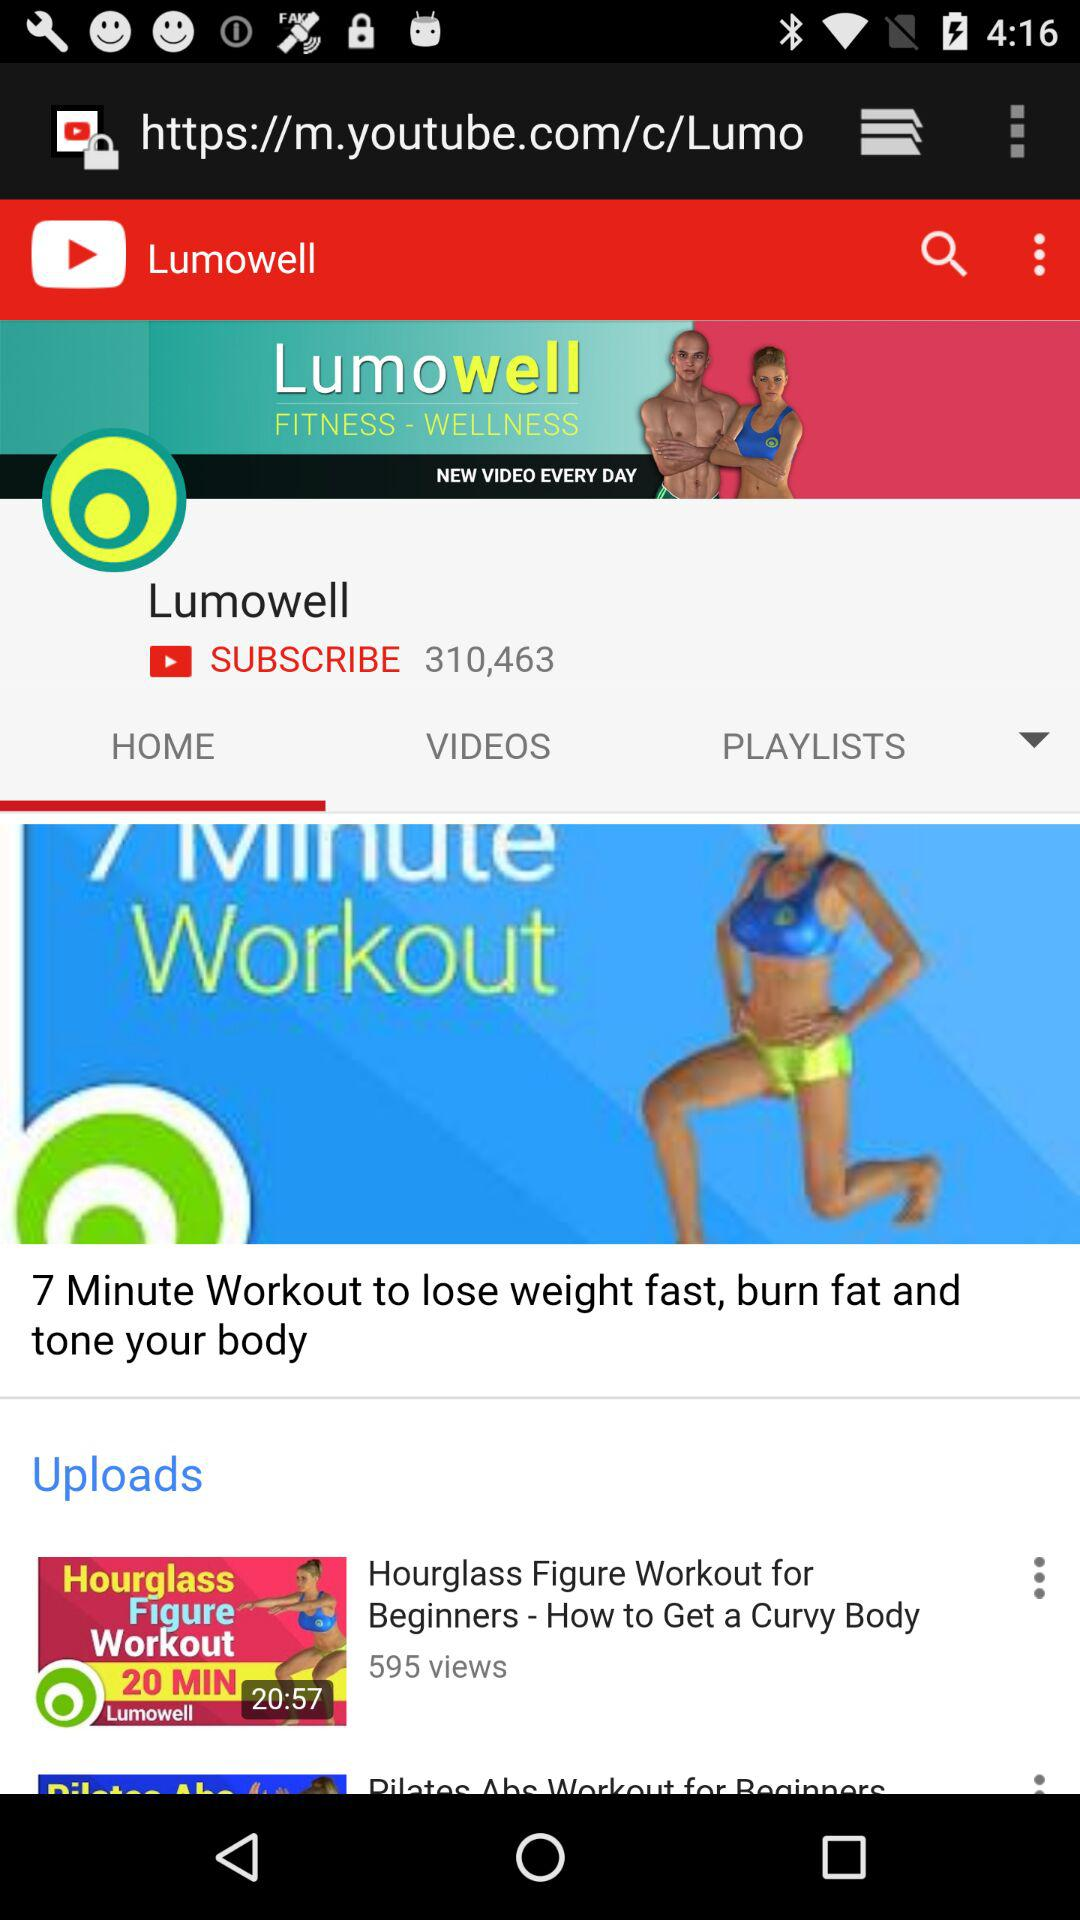How many subscribers are of "Lumowell"? There are 310,463 subscribers. 